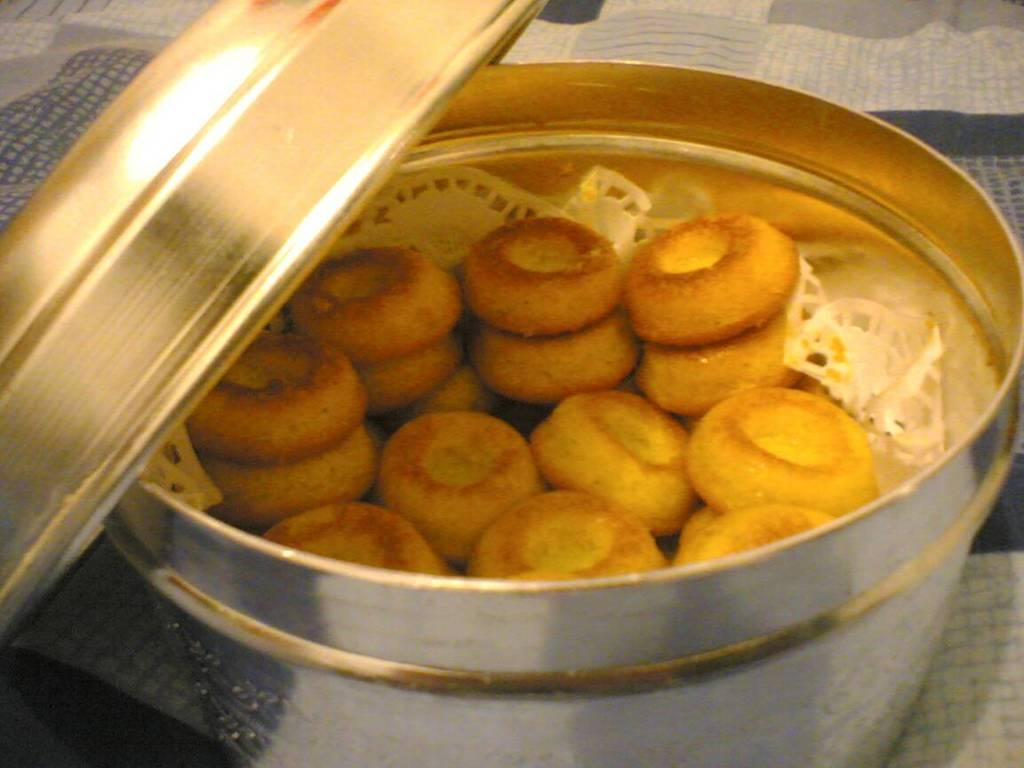What is present in the image related to food? There is food in the image. How is the food contained or stored? The food is in a container. What is the color of the container? The container is silver in color. On what surface is the container placed? The container is on a blue and cream color surface. What type of coat is the person wearing in the image? There is no person present in the image, so it is not possible to determine what type of coat they might be wearing. 